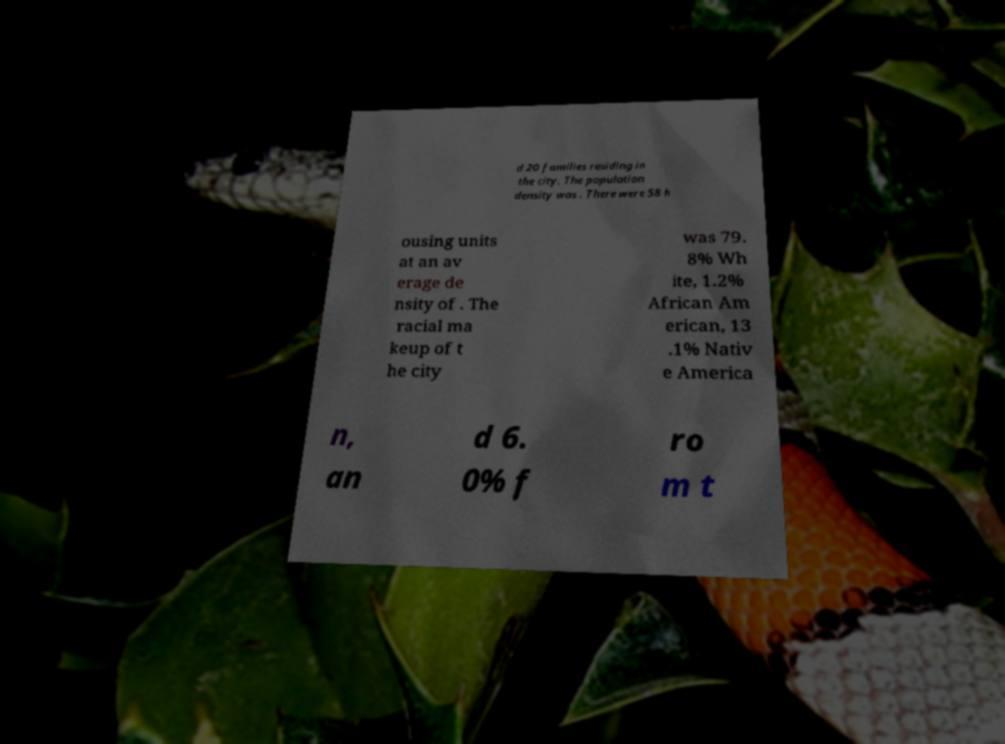What messages or text are displayed in this image? I need them in a readable, typed format. d 20 families residing in the city. The population density was . There were 58 h ousing units at an av erage de nsity of . The racial ma keup of t he city was 79. 8% Wh ite, 1.2% African Am erican, 13 .1% Nativ e America n, an d 6. 0% f ro m t 